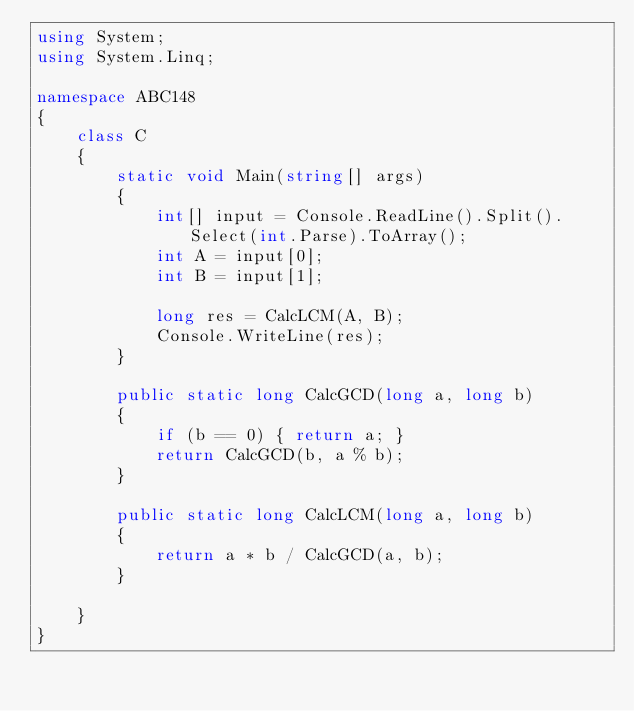<code> <loc_0><loc_0><loc_500><loc_500><_C#_>using System;
using System.Linq;

namespace ABC148
{
    class C
    {
        static void Main(string[] args)
        {
            int[] input = Console.ReadLine().Split().Select(int.Parse).ToArray();
            int A = input[0];
            int B = input[1];

            long res = CalcLCM(A, B);
            Console.WriteLine(res);
        }

        public static long CalcGCD(long a, long b)
        {
            if (b == 0) { return a; }
            return CalcGCD(b, a % b);
        }

        public static long CalcLCM(long a, long b)
        {
            return a * b / CalcGCD(a, b);
        }

    }
}
</code> 